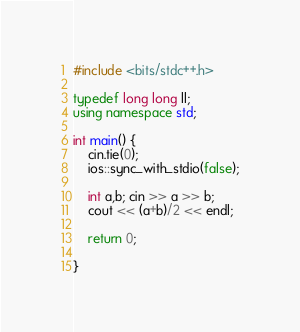Convert code to text. <code><loc_0><loc_0><loc_500><loc_500><_C++_>#include <bits/stdc++.h>

typedef long long ll;
using namespace std;

int main() {
	cin.tie(0);
	ios::sync_with_stdio(false);

	int a,b; cin >> a >> b;
	cout << (a+b)/2 << endl;

	return 0;

}

</code> 